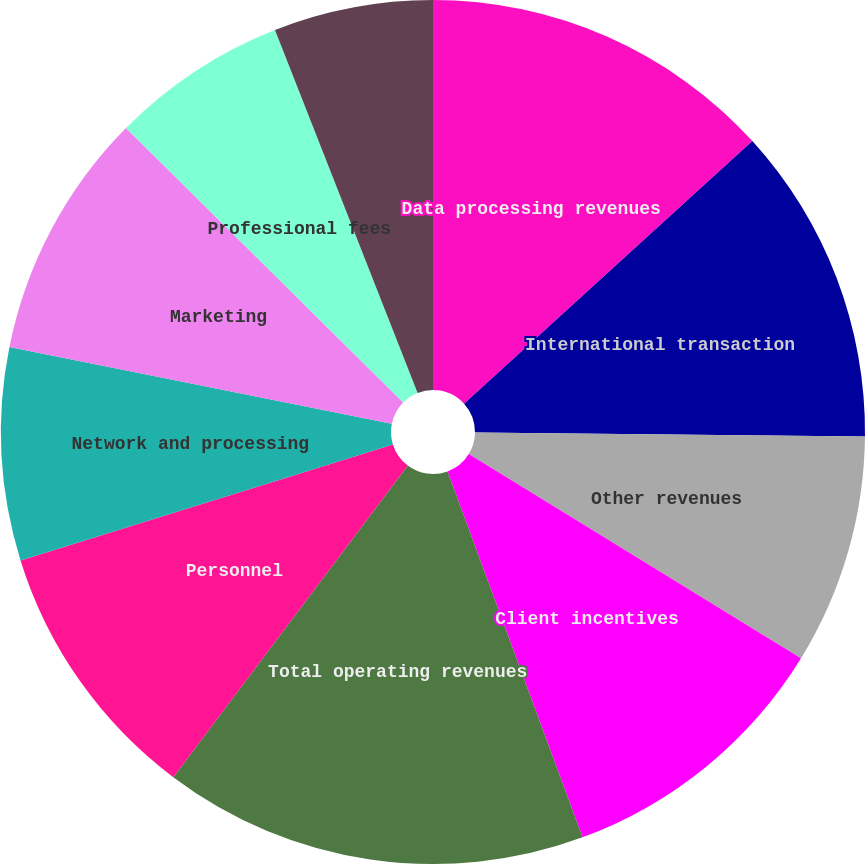Convert chart to OTSL. <chart><loc_0><loc_0><loc_500><loc_500><pie_chart><fcel>Data processing revenues<fcel>International transaction<fcel>Other revenues<fcel>Client incentives<fcel>Total operating revenues<fcel>Personnel<fcel>Network and processing<fcel>Marketing<fcel>Professional fees<fcel>Depreciation and amortization<nl><fcel>13.24%<fcel>11.92%<fcel>8.61%<fcel>10.6%<fcel>15.89%<fcel>9.93%<fcel>7.95%<fcel>9.27%<fcel>6.62%<fcel>5.96%<nl></chart> 